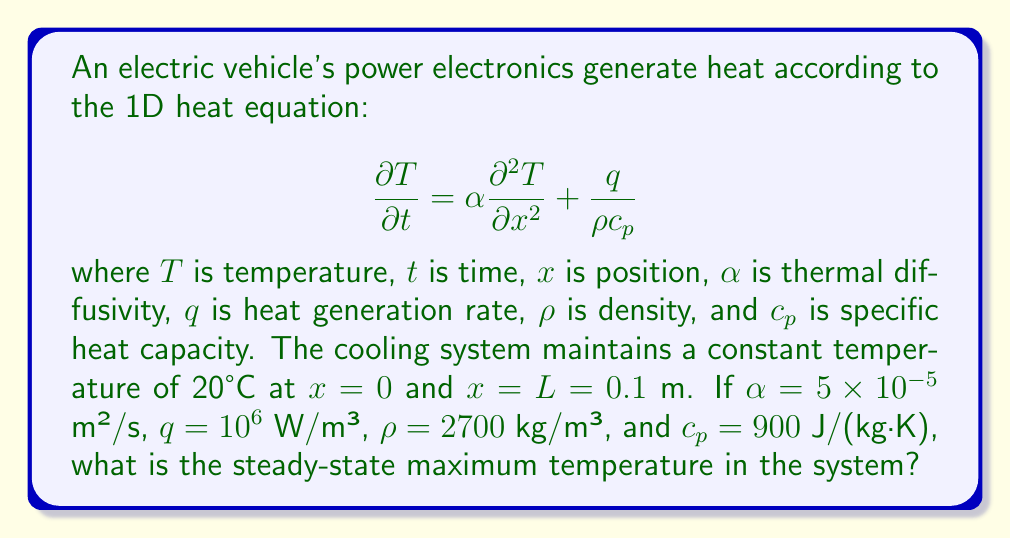Give your solution to this math problem. To solve this problem, we need to follow these steps:

1) For the steady-state solution, $\frac{\partial T}{\partial t} = 0$, so the heat equation becomes:

   $$0 = \alpha \frac{d^2 T}{dx^2} + \frac{q}{\rho c_p}$$

2) Rearrange the equation:

   $$\frac{d^2 T}{dx^2} = -\frac{q}{\alpha \rho c_p}$$

3) Integrate twice:

   $$\frac{dT}{dx} = -\frac{q}{\alpha \rho c_p}x + C_1$$
   $$T = -\frac{q}{2\alpha \rho c_p}x^2 + C_1x + C_2$$

4) Apply the boundary conditions:
   At $x=0$, $T=20$, so $C_2 = 20$
   At $x=L=0.1$, $T=20$, so:

   $$20 = -\frac{q}{2\alpha \rho c_p}(0.1)^2 + 0.1C_1 + 20$$

5) Solve for $C_1$:

   $$C_1 = \frac{q}{2\alpha \rho c_p}L = \frac{10^6}{2(5 \times 10^{-5})(2700)(900)}(0.1) = 411.11$$

6) The temperature distribution is:

   $$T = -\frac{q}{2\alpha \rho c_p}x^2 + 411.11x + 20$$

7) To find the maximum temperature, differentiate and set to zero:

   $$\frac{dT}{dx} = -\frac{q}{\alpha \rho c_p}x + 411.11 = 0$$

   $$x = \frac{411.11 \alpha \rho c_p}{q} = 0.05\text{ m}$$

8) The maximum temperature occurs at $x = 0.05$ m (the middle of the system). Substitute this back into the temperature distribution:

   $$T_{max} = -\frac{10^6}{2(5 \times 10^{-5})(2700)(900)}(0.05)^2 + 411.11(0.05) + 20 = 30.28\text{ °C}$$
Answer: 30.28°C 